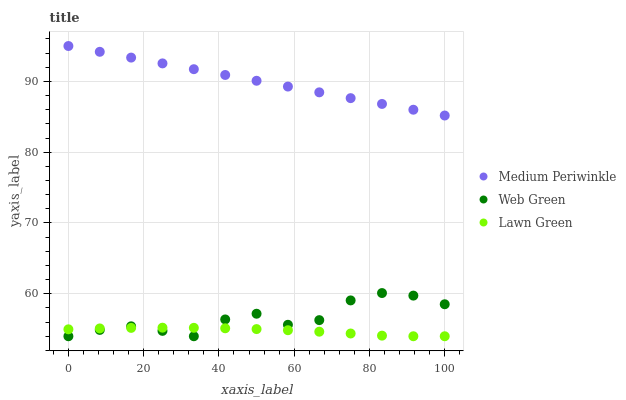Does Lawn Green have the minimum area under the curve?
Answer yes or no. Yes. Does Medium Periwinkle have the maximum area under the curve?
Answer yes or no. Yes. Does Web Green have the minimum area under the curve?
Answer yes or no. No. Does Web Green have the maximum area under the curve?
Answer yes or no. No. Is Medium Periwinkle the smoothest?
Answer yes or no. Yes. Is Web Green the roughest?
Answer yes or no. Yes. Is Web Green the smoothest?
Answer yes or no. No. Is Medium Periwinkle the roughest?
Answer yes or no. No. Does Lawn Green have the lowest value?
Answer yes or no. Yes. Does Medium Periwinkle have the lowest value?
Answer yes or no. No. Does Medium Periwinkle have the highest value?
Answer yes or no. Yes. Does Web Green have the highest value?
Answer yes or no. No. Is Web Green less than Medium Periwinkle?
Answer yes or no. Yes. Is Medium Periwinkle greater than Web Green?
Answer yes or no. Yes. Does Lawn Green intersect Web Green?
Answer yes or no. Yes. Is Lawn Green less than Web Green?
Answer yes or no. No. Is Lawn Green greater than Web Green?
Answer yes or no. No. Does Web Green intersect Medium Periwinkle?
Answer yes or no. No. 